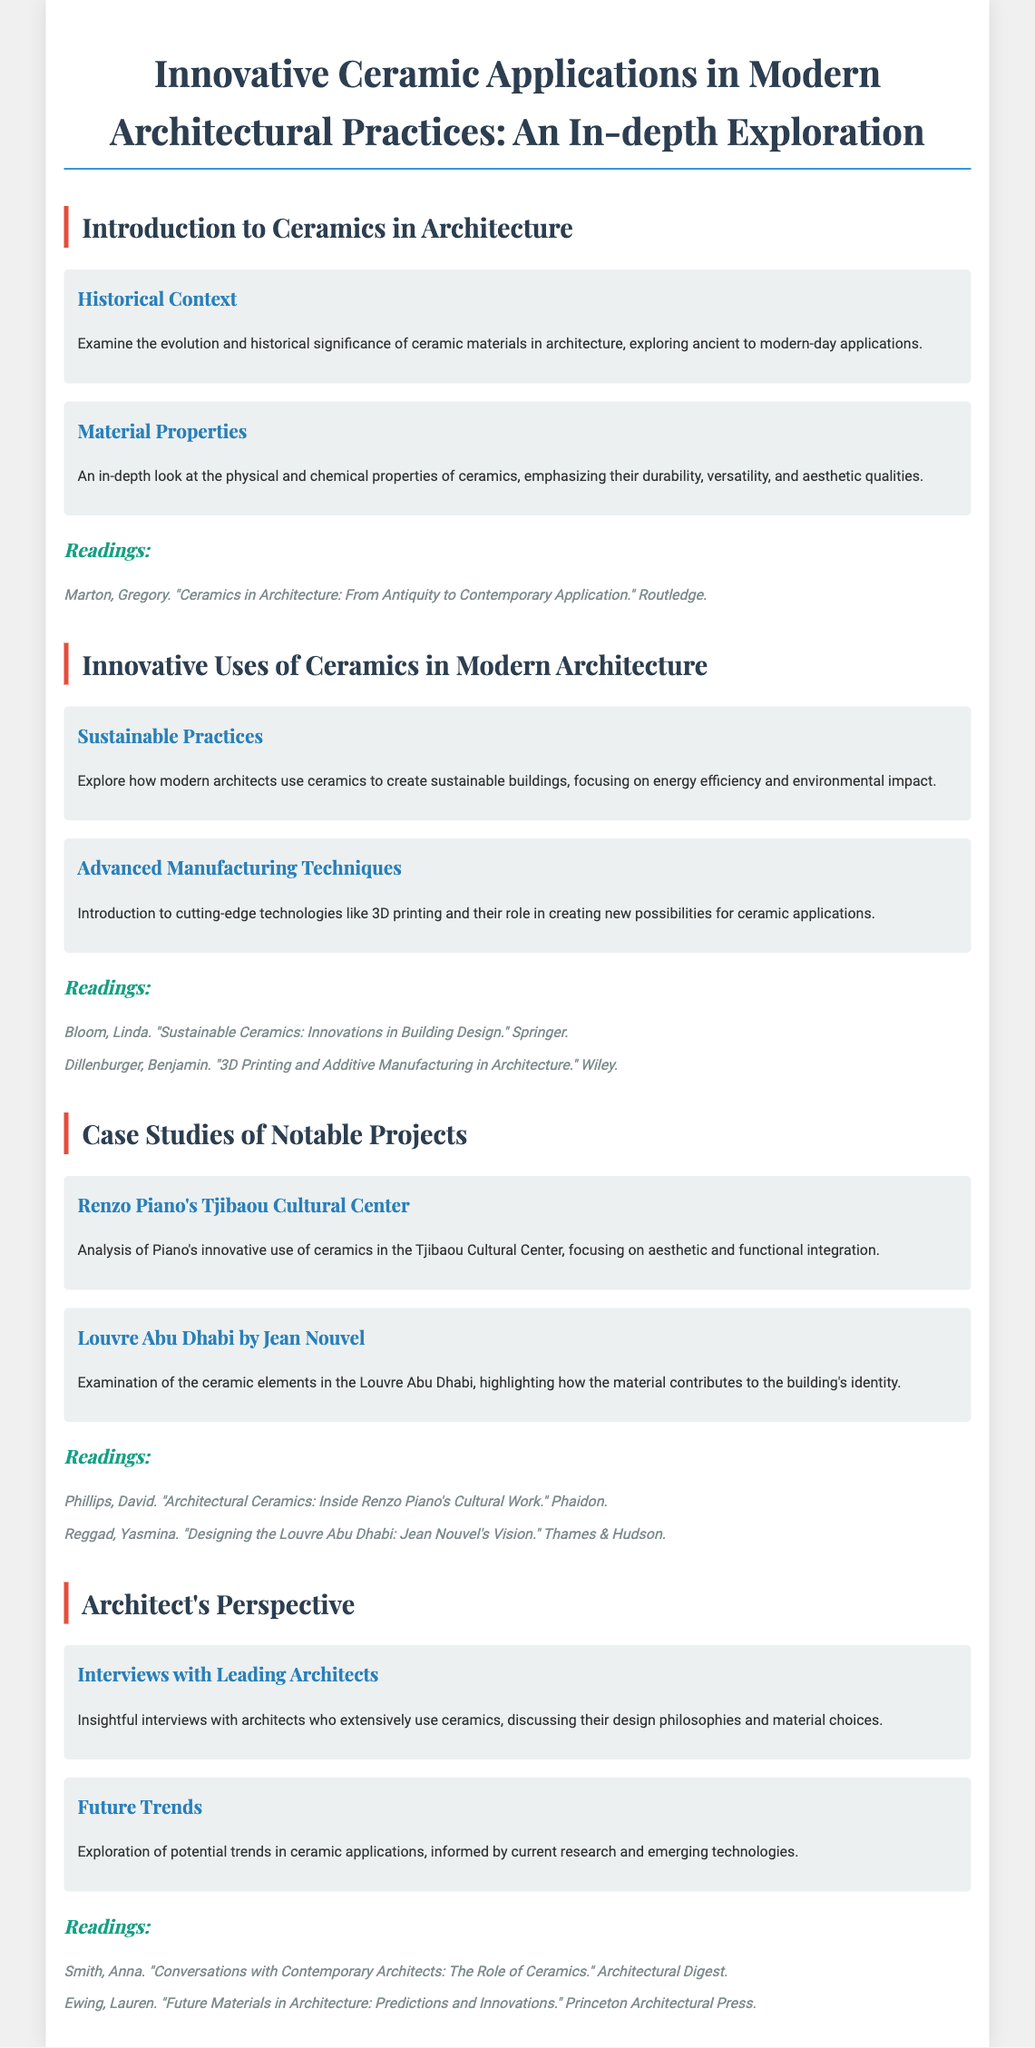what is the main title of the document? The main title of the document is displayed prominently at the top of the rendered content.
Answer: Innovative Ceramic Applications in Modern Architectural Practices: An In-depth Exploration who authored the reading titled "Sustainable Ceramics: Innovations in Building Design"? The author is listed along with the title in the readings section of the relevant module.
Answer: Linda Bloom which architectural project features in the case study section alongside Renzo Piano's Tjibaou Cultural Center? The document mentions projects in a comparative analysis format under the same section.
Answer: Louvre Abu Dhabi by Jean Nouvel how many modules are included in the syllabus? The number of main sections or categories is summarized in the document's structure.
Answer: Four what is the focus of the topic "Advanced Manufacturing Techniques"? The document specifies the subject area addressed in this topic section.
Answer: Introduction to cutting-edge technologies like 3D printing who is the publisher of the reading "Architectural Ceramics: Inside Renzo Piano's Cultural Work"? The publisher is mentioned next to the title within the readings of the corresponding module.
Answer: Phaidon what type of interviews are included in the Architect's Perspective module? This reflects the content and nature of the discussions held within that module.
Answer: Insightful interviews with architects what color is used for the headings in the document? The document uses a specific color scheme reflected in the design for headings.
Answer: #2c3e50 